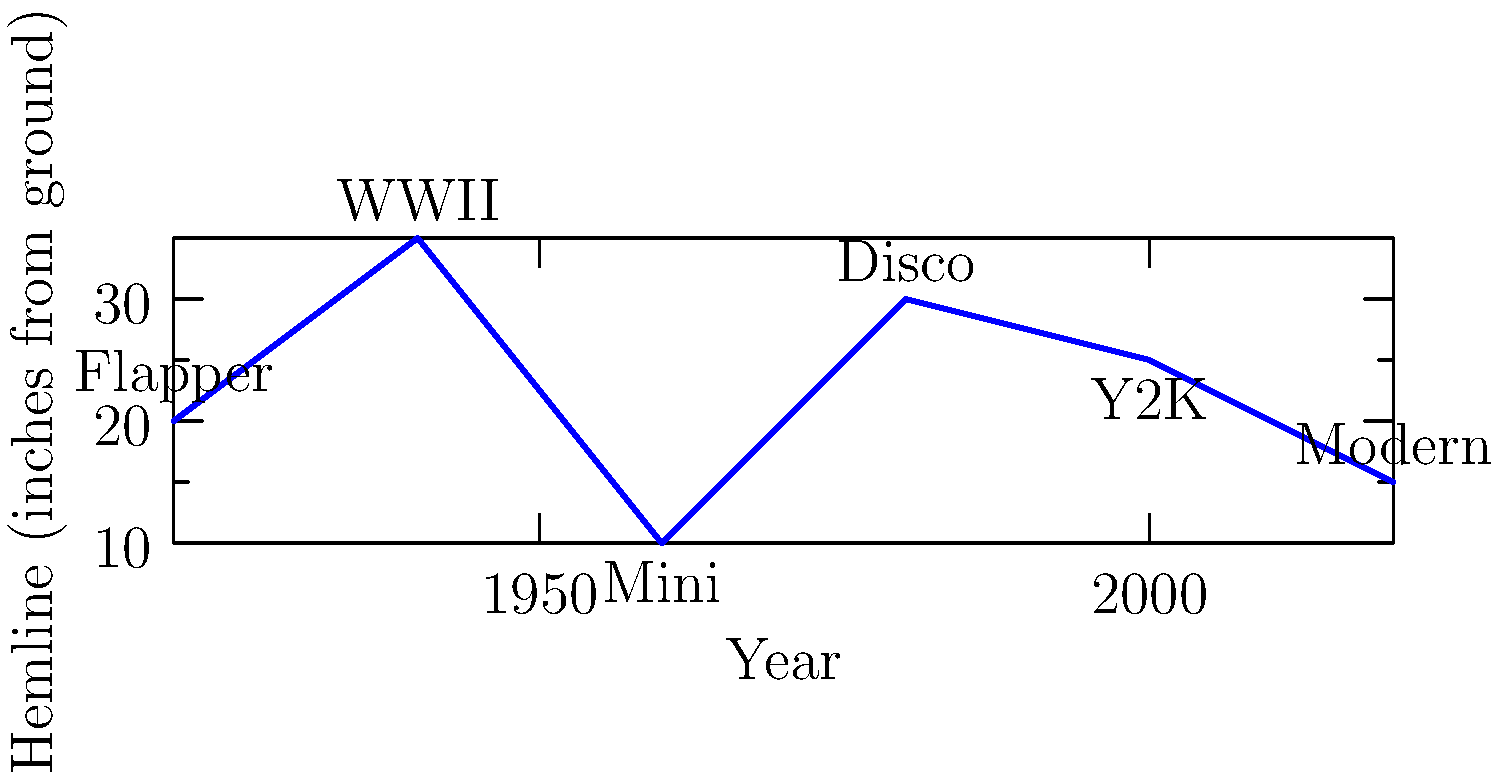Analyze the graph depicting women's hemline trends from 1920 to 2020. Which decade saw the most dramatic shift in hemline length, and how might this reflect broader societal changes? Consider the historical context and its impact on fashion as a form of expression and liberation. To answer this question, we need to examine the graph and consider historical context:

1. Analyze the graph:
   - 1920s: Hemline at 20 inches from the ground
   - 1940s: Rises to 35 inches
   - 1960s: Drops dramatically to 10 inches
   - 1980s: Rises again to 30 inches
   - 2000s: Slight drop to 25 inches
   - 2020s: Further drop to 15 inches

2. Identify the most dramatic shift:
   The most significant change occurs between the 1940s and 1960s, with a drop of 25 inches.

3. Historical context:
   - 1940s: World War II era, practical clothing
   - 1960s: Sexual revolution, women's liberation movement

4. Societal changes reflected:
   - The dramatic shortening of hemlines in the 1960s coincides with:
     a) Second-wave feminism
     b) Youth culture and rebellion
     c) Changing attitudes towards sexuality and body autonomy

5. Fashion as expression and liberation:
   - Mini skirts of the 1960s symbolized:
     a) Rejection of traditional gender roles
     b) Sexual liberation
     c) Youthful defiance of older generations' norms

6. Impact on gender studies:
   This shift demonstrates how fashion can be a powerful tool for analyzing changing gender norms, societal expectations, and women's empowerment throughout history.
Answer: 1960s: Mini skirt revolution reflecting women's liberation and changing societal norms. 